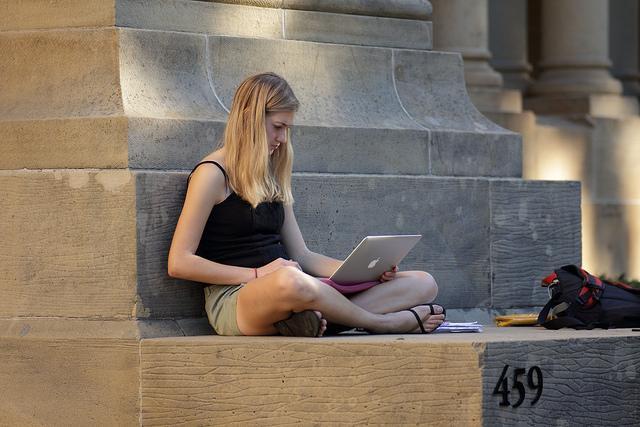How many zebras are there?
Give a very brief answer. 0. 